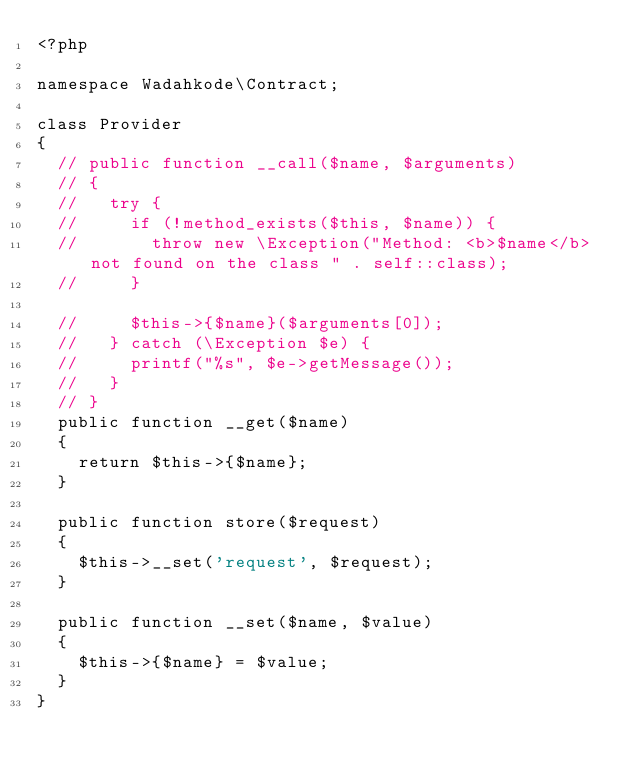<code> <loc_0><loc_0><loc_500><loc_500><_PHP_><?php

namespace Wadahkode\Contract;

class Provider
{
  // public function __call($name, $arguments)
  // {
  //   try {
  //     if (!method_exists($this, $name)) {
  //       throw new \Exception("Method: <b>$name</b> not found on the class " . self::class);
  //     }

  //     $this->{$name}($arguments[0]);
  //   } catch (\Exception $e) {
  //     printf("%s", $e->getMessage());
  //   }
  // }
  public function __get($name)
  {
    return $this->{$name};
  }

  public function store($request)
  {
    $this->__set('request', $request);
  }

  public function __set($name, $value)
  {
    $this->{$name} = $value;
  }
}</code> 